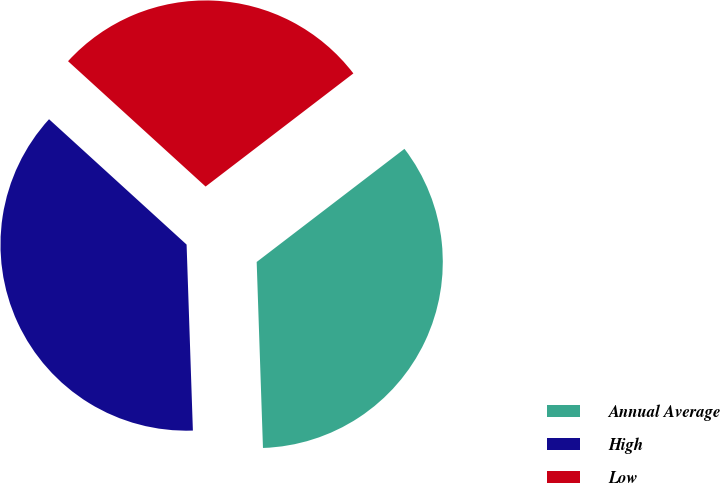Convert chart. <chart><loc_0><loc_0><loc_500><loc_500><pie_chart><fcel>Annual Average<fcel>High<fcel>Low<nl><fcel>34.86%<fcel>37.3%<fcel>27.84%<nl></chart> 